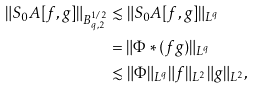<formula> <loc_0><loc_0><loc_500><loc_500>\| S _ { 0 } A [ f , g ] \| _ { B ^ { 1 / 2 } _ { q , 2 } } & \lesssim \| S _ { 0 } A [ f , g ] \| _ { L ^ { q } } \\ & = \| \Phi \ast ( f g ) \| _ { L ^ { q } } \\ & \lesssim \| \Phi \| _ { L ^ { q } } \| f \| _ { L ^ { 2 } } \| g \| _ { L ^ { 2 } } ,</formula> 